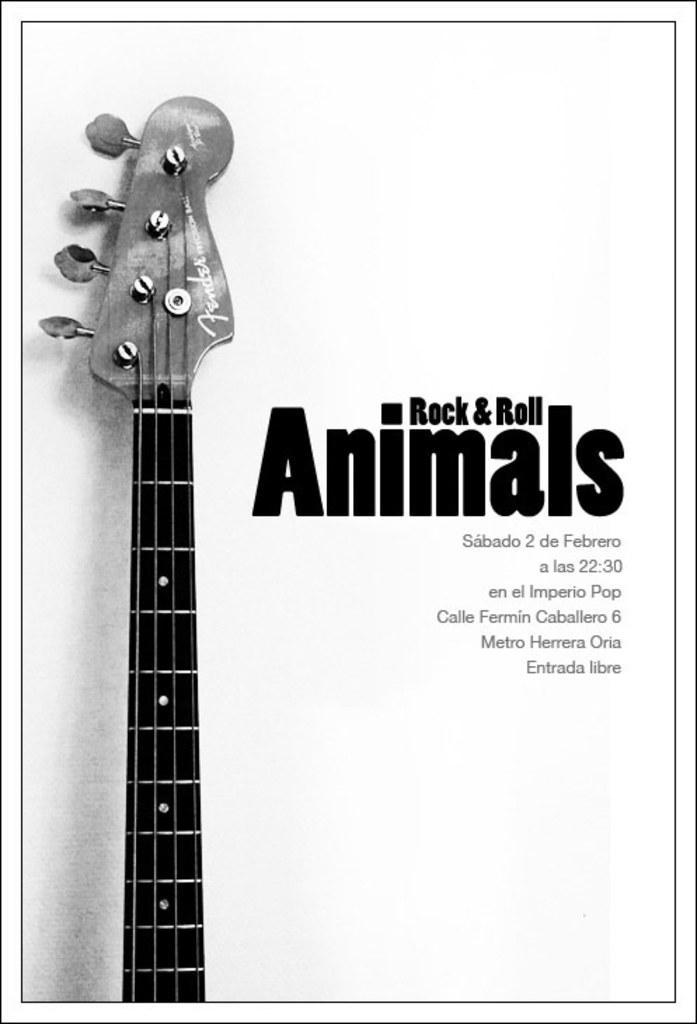Describe this image in one or two sentences. This is a black and white image. In this image we can see the picture of a guitar and some text beside it. 